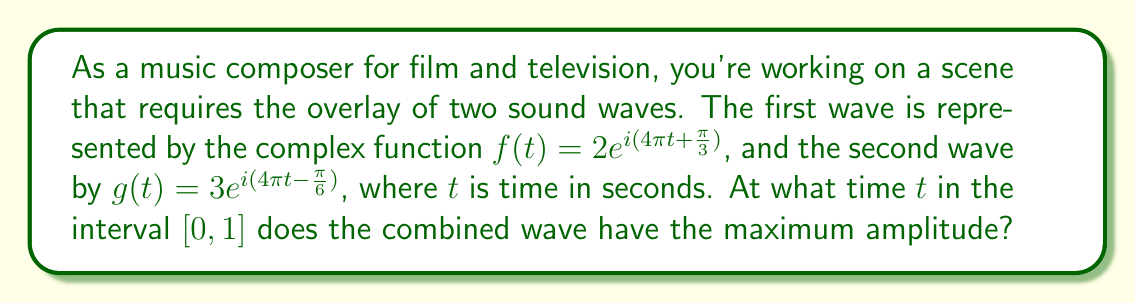Show me your answer to this math problem. To solve this problem, we'll follow these steps:

1) The combined wave is the sum of the two waves: $h(t) = f(t) + g(t)$

2) $h(t) = 2e^{i(4\pi t + \frac{\pi}{3})} + 3e^{i(4\pi t - \frac{\pi}{6})}$

3) We can factor out the common $e^{i4\pi t}$:
   $h(t) = e^{i4\pi t}(2e^{i\frac{\pi}{3}} + 3e^{-i\frac{\pi}{6}})$

4) The amplitude of the combined wave is given by the magnitude of $h(t)$:
   $|h(t)| = |e^{i4\pi t}||2e^{i\frac{\pi}{3}} + 3e^{-i\frac{\pi}{6}}|$

5) Since $|e^{i4\pi t}| = 1$ for all $t$, the amplitude depends only on the second factor:
   $|h(t)| = |2e^{i\frac{\pi}{3}} + 3e^{-i\frac{\pi}{6}}|$

6) This is a constant value, independent of $t$. Therefore, the amplitude is the same for all $t$.

7) To find this constant amplitude, we can calculate:
   $2e^{i\frac{\pi}{3}} = 1 + i\sqrt{3}$
   $3e^{-i\frac{\pi}{6}} = \frac{3\sqrt{3}}{2} - \frac{3i}{2}$

8) Adding these:
   $(1 + i\sqrt{3}) + (\frac{3\sqrt{3}}{2} - \frac{3i}{2}) = (1 + \frac{3\sqrt{3}}{2}) + i(\sqrt{3} - \frac{3}{2})$

9) The magnitude of this complex number is:
   $\sqrt{(1 + \frac{3\sqrt{3}}{2})^2 + (\sqrt{3} - \frac{3}{2})^2} = \sqrt{4 + 3\sqrt{3}} \approx 3.41$

Therefore, the combined wave has a constant amplitude of $\sqrt{4 + 3\sqrt{3}}$ for all $t$ in $[0, 1]$.
Answer: All $t \in [0, 1]$ 